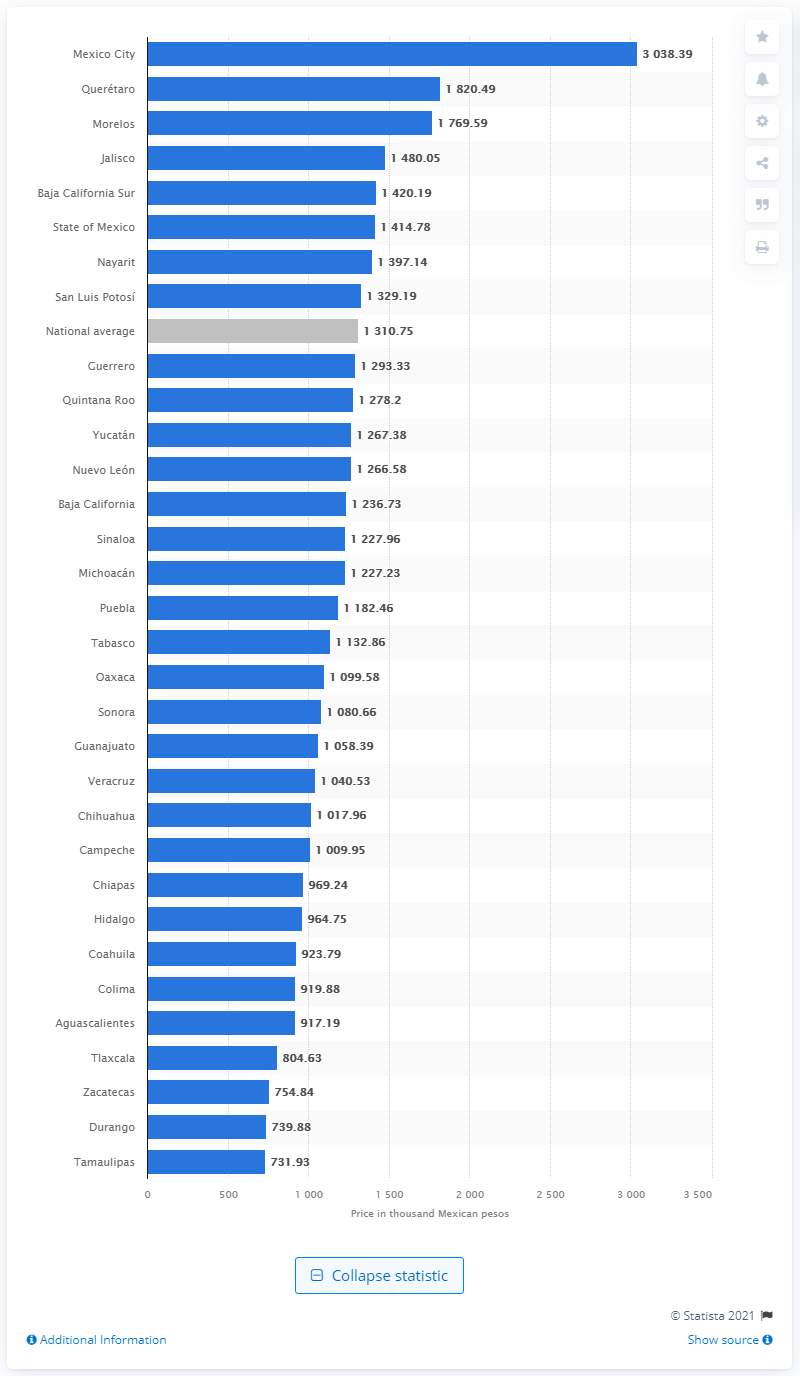Outline some significant characteristics in this image. In 2021, the most expensive place to buy residential property in Mexico was Mexico City, with the highest prices ever recorded. 